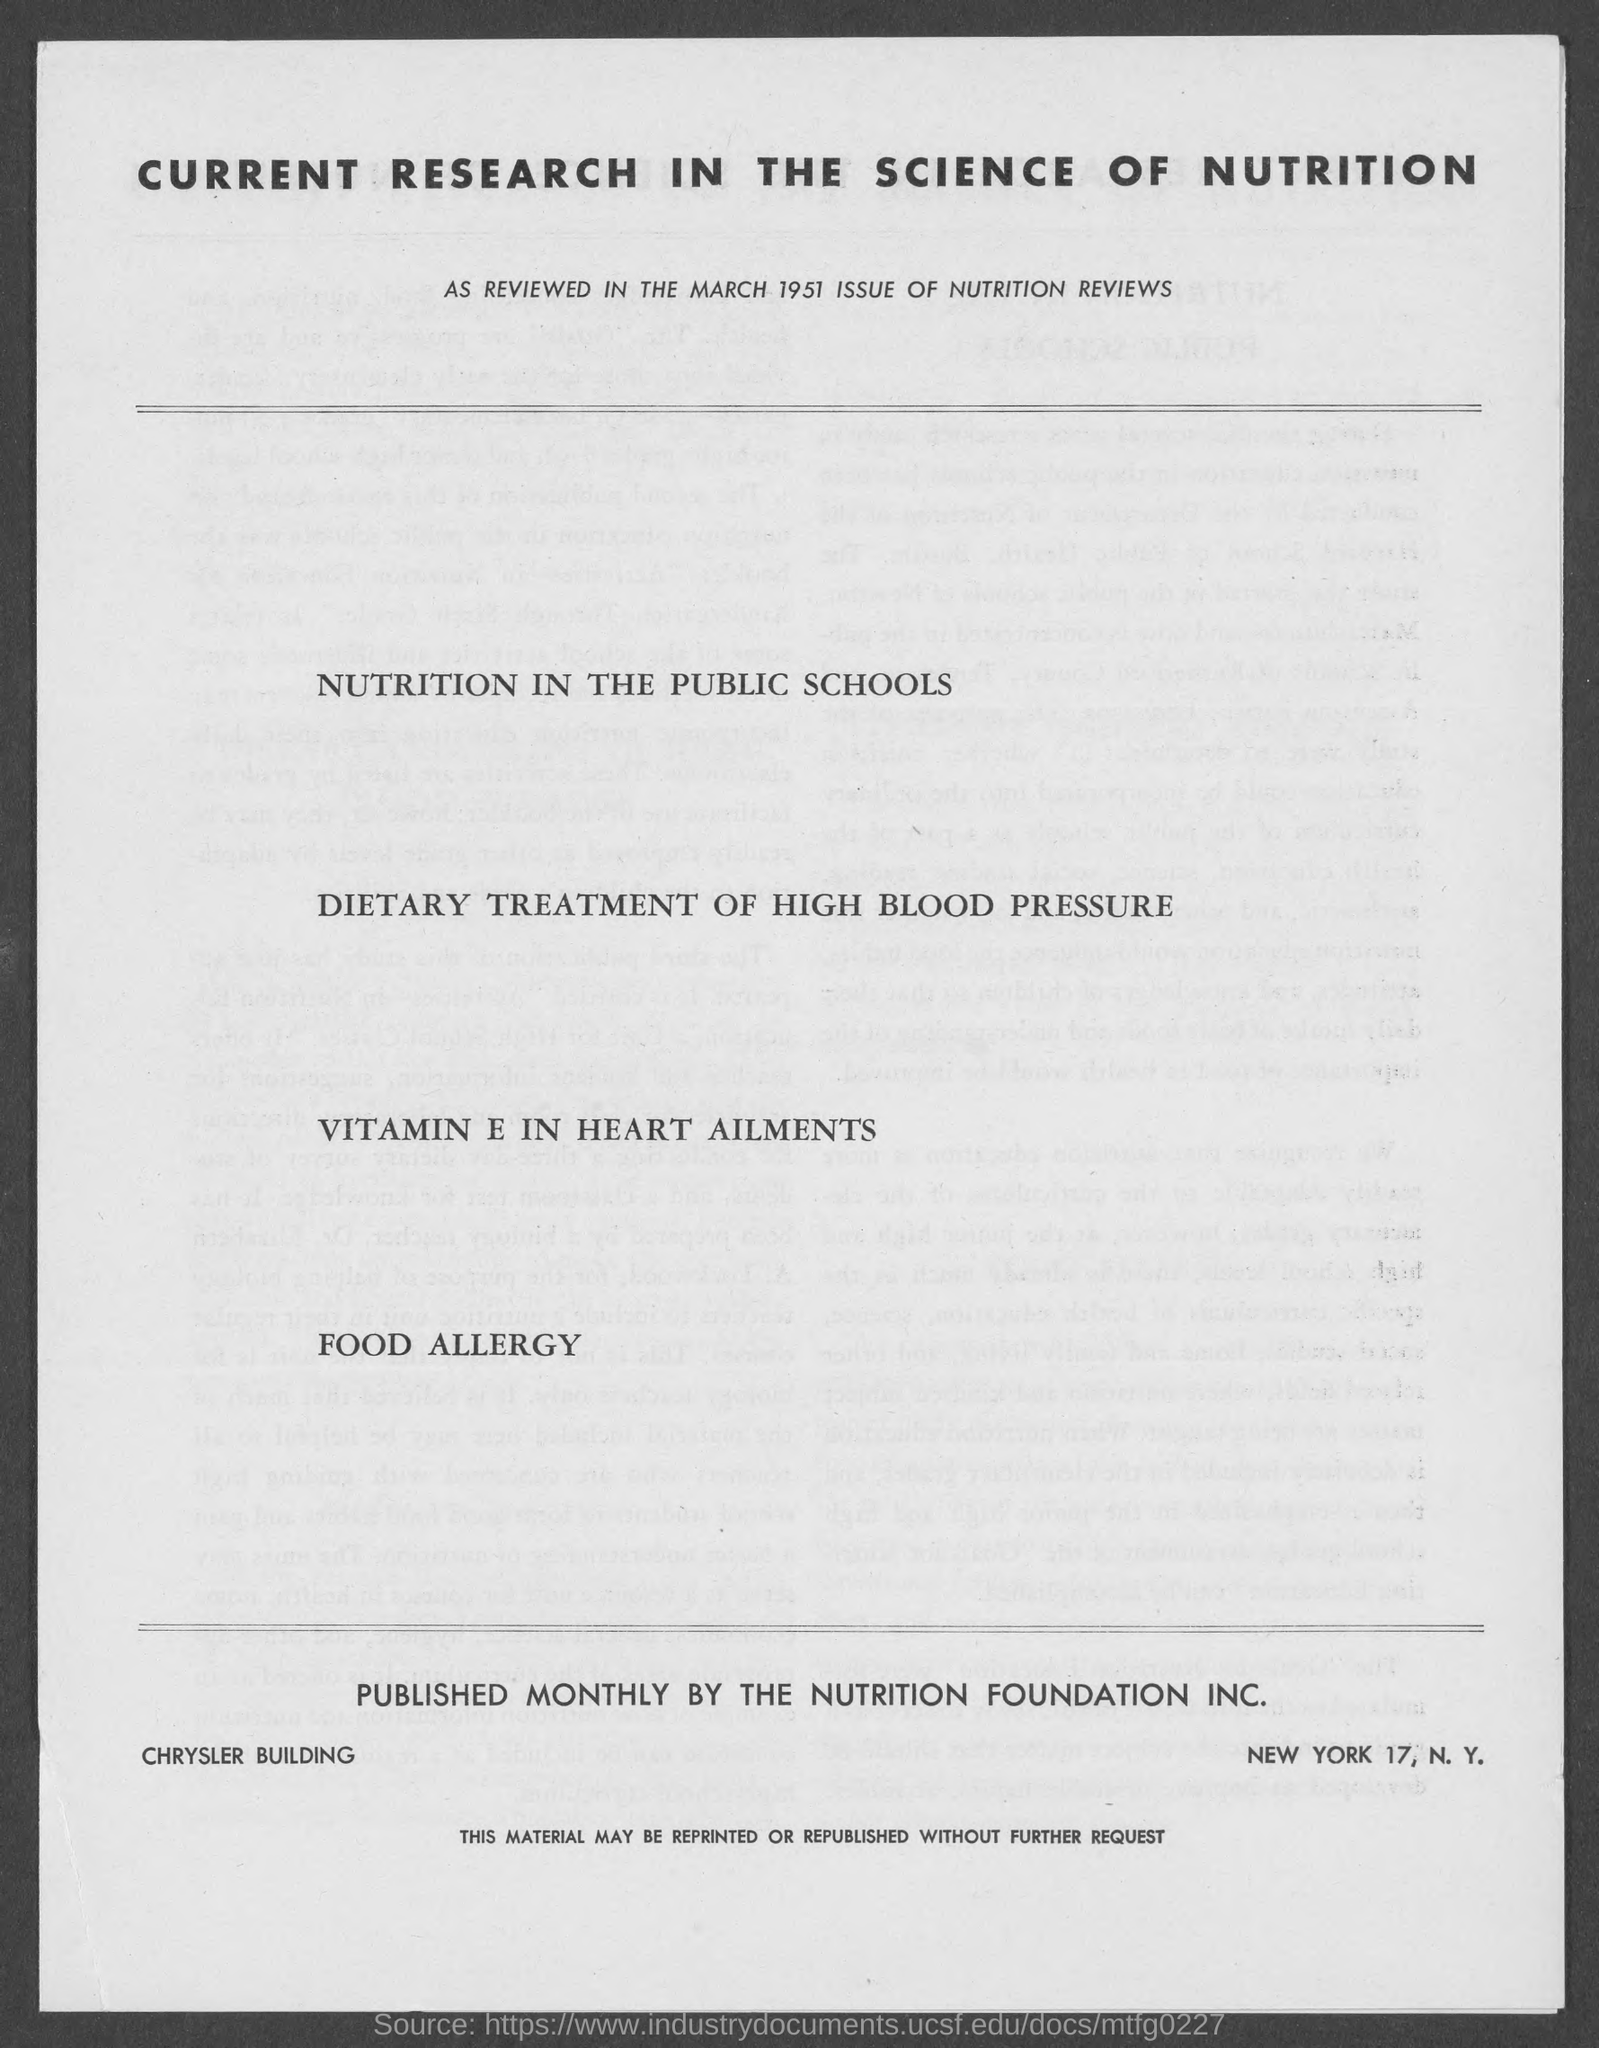Outline some significant characteristics in this image. The Chrysler Building is the name of a building that was mentioned. The review was conducted in the year 1951. Published monthly by the Nutrition Foundation, Inc., a foundation dedicated to promoting nutrition education and research. 